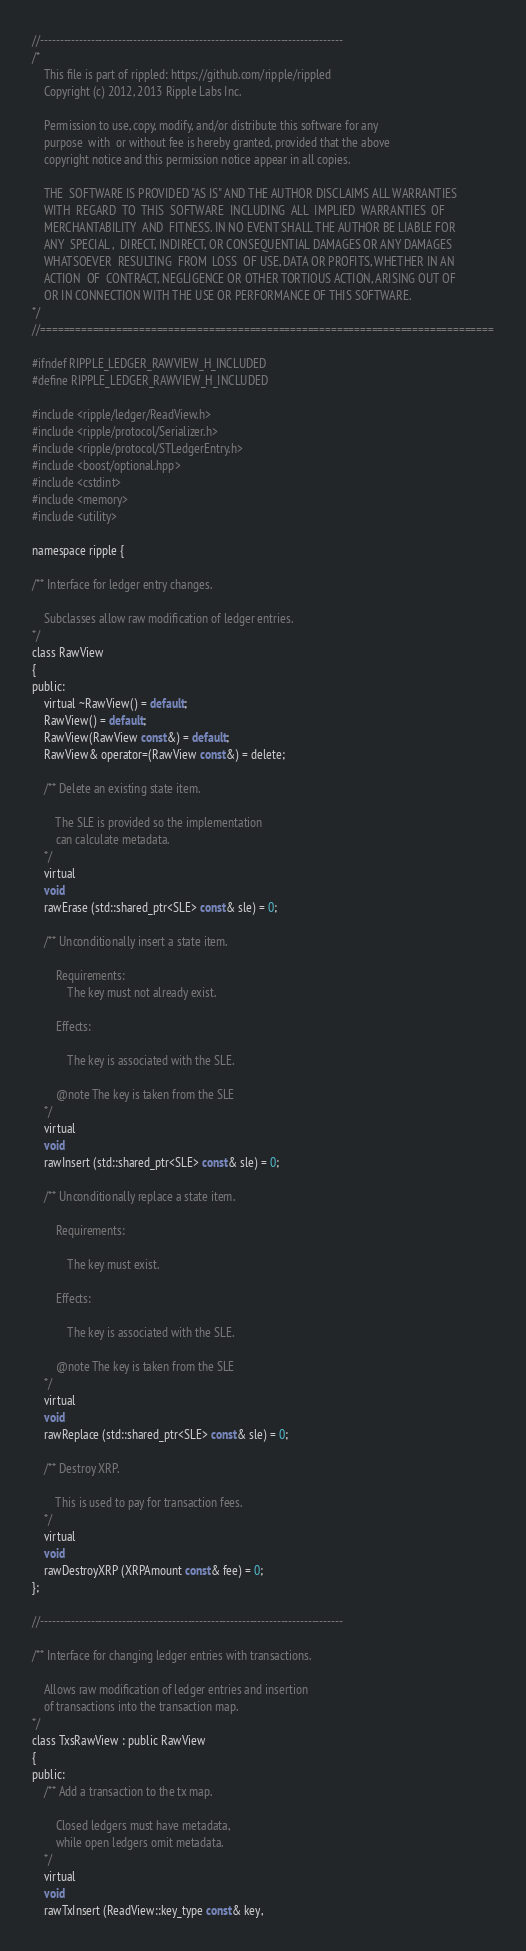Convert code to text. <code><loc_0><loc_0><loc_500><loc_500><_C_>//------------------------------------------------------------------------------
/*
    This file is part of rippled: https://github.com/ripple/rippled
    Copyright (c) 2012, 2013 Ripple Labs Inc.

    Permission to use, copy, modify, and/or distribute this software for any
    purpose  with  or without fee is hereby granted, provided that the above
    copyright notice and this permission notice appear in all copies.

    THE  SOFTWARE IS PROVIDED "AS IS" AND THE AUTHOR DISCLAIMS ALL WARRANTIES
    WITH  REGARD  TO  THIS  SOFTWARE  INCLUDING  ALL  IMPLIED  WARRANTIES  OF
    MERCHANTABILITY  AND  FITNESS. IN NO EVENT SHALL THE AUTHOR BE LIABLE FOR
    ANY  SPECIAL ,  DIRECT, INDIRECT, OR CONSEQUENTIAL DAMAGES OR ANY DAMAGES
    WHATSOEVER  RESULTING  FROM  LOSS  OF USE, DATA OR PROFITS, WHETHER IN AN
    ACTION  OF  CONTRACT, NEGLIGENCE OR OTHER TORTIOUS ACTION, ARISING OUT OF
    OR IN CONNECTION WITH THE USE OR PERFORMANCE OF THIS SOFTWARE.
*/
//==============================================================================

#ifndef RIPPLE_LEDGER_RAWVIEW_H_INCLUDED
#define RIPPLE_LEDGER_RAWVIEW_H_INCLUDED

#include <ripple/ledger/ReadView.h>
#include <ripple/protocol/Serializer.h>
#include <ripple/protocol/STLedgerEntry.h>
#include <boost/optional.hpp>
#include <cstdint>
#include <memory>
#include <utility>

namespace ripple {

/** Interface for ledger entry changes.

    Subclasses allow raw modification of ledger entries.
*/
class RawView
{
public:
    virtual ~RawView() = default;
    RawView() = default;
    RawView(RawView const&) = default;
    RawView& operator=(RawView const&) = delete;

    /** Delete an existing state item.

        The SLE is provided so the implementation
        can calculate metadata.
    */
    virtual
    void
    rawErase (std::shared_ptr<SLE> const& sle) = 0;

    /** Unconditionally insert a state item.

        Requirements:
            The key must not already exist.

        Effects:

            The key is associated with the SLE.

        @note The key is taken from the SLE
    */
    virtual
    void
    rawInsert (std::shared_ptr<SLE> const& sle) = 0;

    /** Unconditionally replace a state item.

        Requirements:

            The key must exist.

        Effects:

            The key is associated with the SLE.

        @note The key is taken from the SLE
    */
    virtual
    void
    rawReplace (std::shared_ptr<SLE> const& sle) = 0;

    /** Destroy XRP.

        This is used to pay for transaction fees.
    */
    virtual
    void
    rawDestroyXRP (XRPAmount const& fee) = 0;
};

//------------------------------------------------------------------------------

/** Interface for changing ledger entries with transactions.

    Allows raw modification of ledger entries and insertion
    of transactions into the transaction map.
*/
class TxsRawView : public RawView
{
public:
    /** Add a transaction to the tx map.

        Closed ledgers must have metadata,
        while open ledgers omit metadata.
    */
    virtual
    void
    rawTxInsert (ReadView::key_type const& key,</code> 